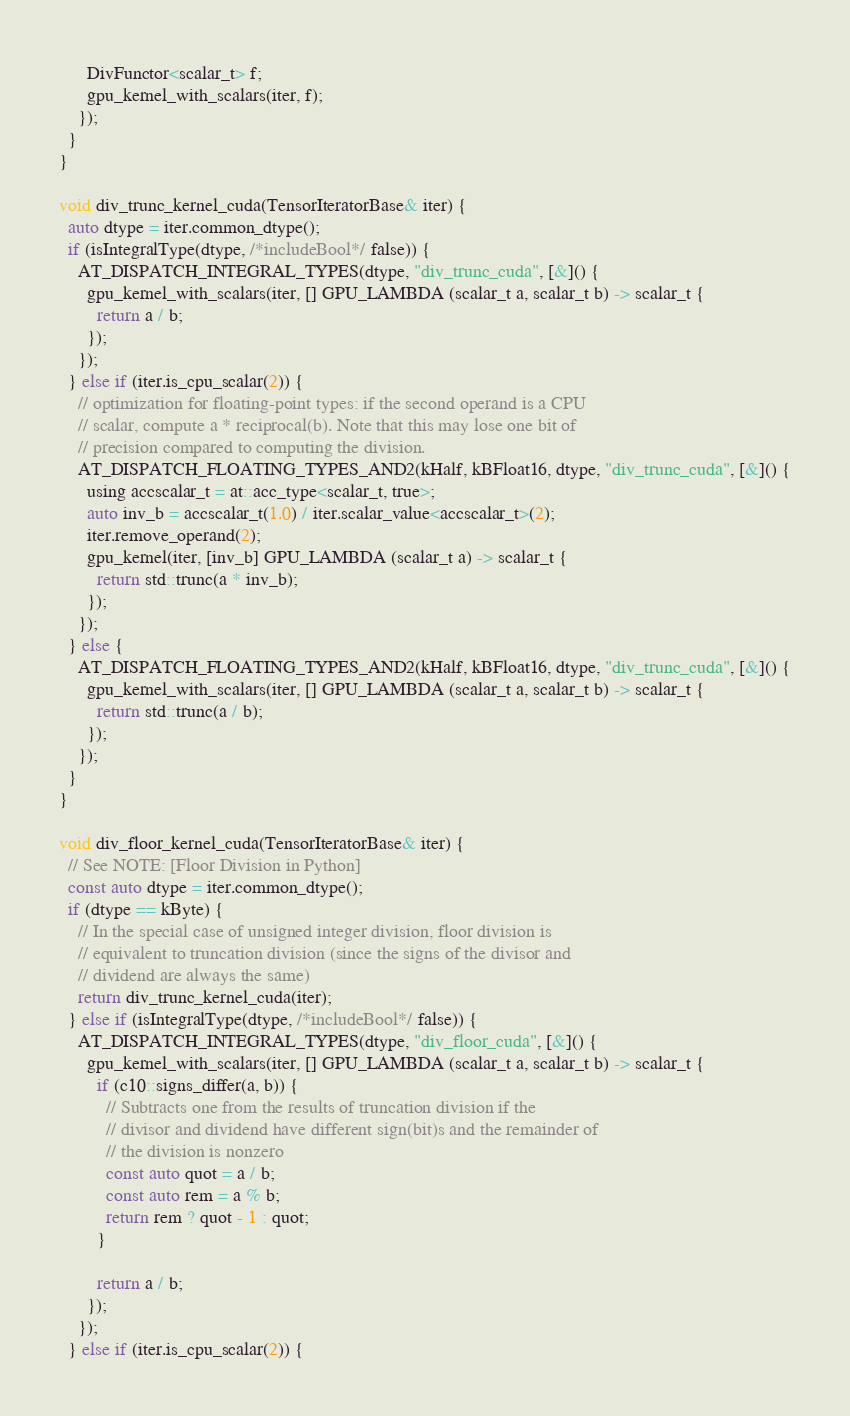<code> <loc_0><loc_0><loc_500><loc_500><_Cuda_>      DivFunctor<scalar_t> f;
      gpu_kernel_with_scalars(iter, f);
    });
  }
}

void div_trunc_kernel_cuda(TensorIteratorBase& iter) {
  auto dtype = iter.common_dtype();
  if (isIntegralType(dtype, /*includeBool*/ false)) {
    AT_DISPATCH_INTEGRAL_TYPES(dtype, "div_trunc_cuda", [&]() {
      gpu_kernel_with_scalars(iter, [] GPU_LAMBDA (scalar_t a, scalar_t b) -> scalar_t {
        return a / b;
      });
    });
  } else if (iter.is_cpu_scalar(2)) {
    // optimization for floating-point types: if the second operand is a CPU
    // scalar, compute a * reciprocal(b). Note that this may lose one bit of
    // precision compared to computing the division.
    AT_DISPATCH_FLOATING_TYPES_AND2(kHalf, kBFloat16, dtype, "div_trunc_cuda", [&]() {
      using accscalar_t = at::acc_type<scalar_t, true>;
      auto inv_b = accscalar_t(1.0) / iter.scalar_value<accscalar_t>(2);
      iter.remove_operand(2);
      gpu_kernel(iter, [inv_b] GPU_LAMBDA (scalar_t a) -> scalar_t {
        return std::trunc(a * inv_b);
      });
    });
  } else {
    AT_DISPATCH_FLOATING_TYPES_AND2(kHalf, kBFloat16, dtype, "div_trunc_cuda", [&]() {
      gpu_kernel_with_scalars(iter, [] GPU_LAMBDA (scalar_t a, scalar_t b) -> scalar_t {
        return std::trunc(a / b);
      });
    });
  }
}

void div_floor_kernel_cuda(TensorIteratorBase& iter) {
  // See NOTE: [Floor Division in Python]
  const auto dtype = iter.common_dtype();
  if (dtype == kByte) {
    // In the special case of unsigned integer division, floor division is
    // equivalent to truncation division (since the signs of the divisor and
    // dividend are always the same)
    return div_trunc_kernel_cuda(iter);
  } else if (isIntegralType(dtype, /*includeBool*/ false)) {
    AT_DISPATCH_INTEGRAL_TYPES(dtype, "div_floor_cuda", [&]() {
      gpu_kernel_with_scalars(iter, [] GPU_LAMBDA (scalar_t a, scalar_t b) -> scalar_t {
        if (c10::signs_differ(a, b)) {
          // Subtracts one from the results of truncation division if the
          // divisor and dividend have different sign(bit)s and the remainder of
          // the division is nonzero
          const auto quot = a / b;
          const auto rem = a % b;
          return rem ? quot - 1 : quot;
        }

        return a / b;
      });
    });
  } else if (iter.is_cpu_scalar(2)) {</code> 